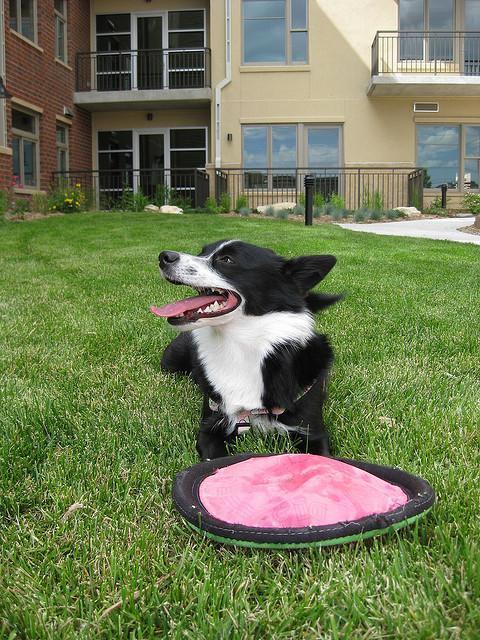How many dogs are in the picture?
Give a very brief answer. 1. How many ties is this man wearing?
Give a very brief answer. 0. 